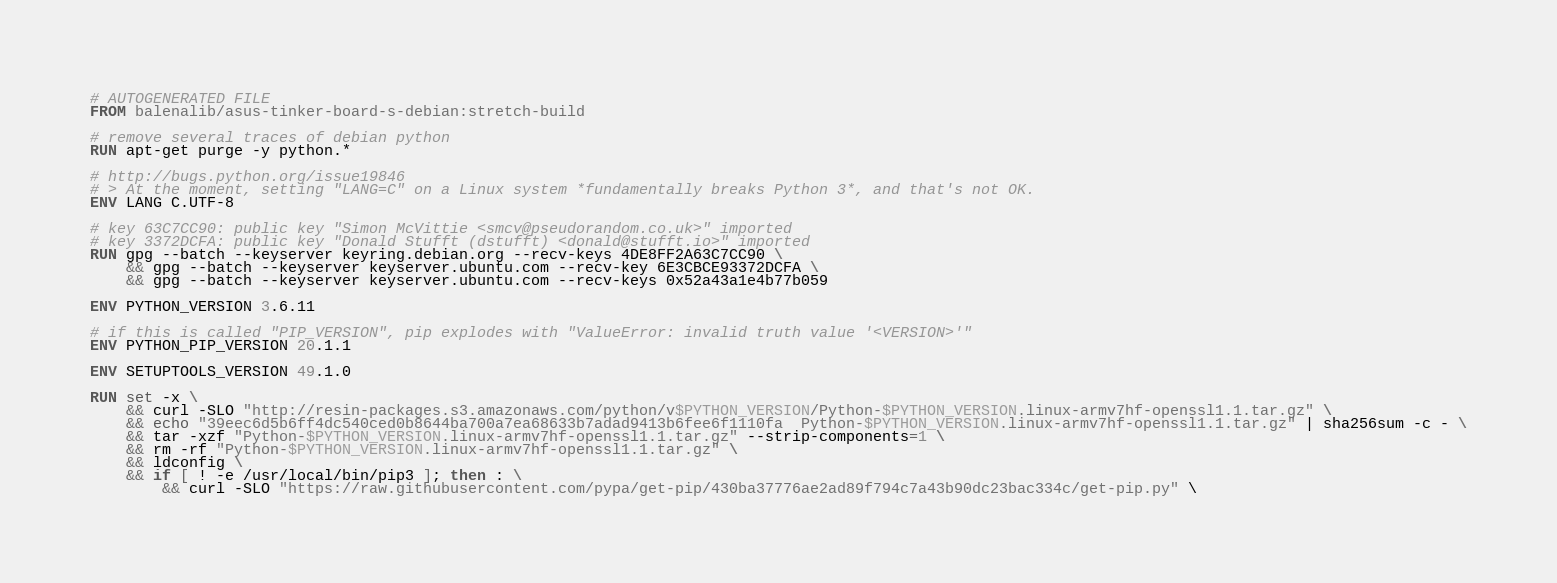Convert code to text. <code><loc_0><loc_0><loc_500><loc_500><_Dockerfile_># AUTOGENERATED FILE
FROM balenalib/asus-tinker-board-s-debian:stretch-build

# remove several traces of debian python
RUN apt-get purge -y python.*

# http://bugs.python.org/issue19846
# > At the moment, setting "LANG=C" on a Linux system *fundamentally breaks Python 3*, and that's not OK.
ENV LANG C.UTF-8

# key 63C7CC90: public key "Simon McVittie <smcv@pseudorandom.co.uk>" imported
# key 3372DCFA: public key "Donald Stufft (dstufft) <donald@stufft.io>" imported
RUN gpg --batch --keyserver keyring.debian.org --recv-keys 4DE8FF2A63C7CC90 \
	&& gpg --batch --keyserver keyserver.ubuntu.com --recv-key 6E3CBCE93372DCFA \
	&& gpg --batch --keyserver keyserver.ubuntu.com --recv-keys 0x52a43a1e4b77b059

ENV PYTHON_VERSION 3.6.11

# if this is called "PIP_VERSION", pip explodes with "ValueError: invalid truth value '<VERSION>'"
ENV PYTHON_PIP_VERSION 20.1.1

ENV SETUPTOOLS_VERSION 49.1.0

RUN set -x \
	&& curl -SLO "http://resin-packages.s3.amazonaws.com/python/v$PYTHON_VERSION/Python-$PYTHON_VERSION.linux-armv7hf-openssl1.1.tar.gz" \
	&& echo "39eec6d5b6ff4dc540ced0b8644ba700a7ea68633b7adad9413b6fee6f1110fa  Python-$PYTHON_VERSION.linux-armv7hf-openssl1.1.tar.gz" | sha256sum -c - \
	&& tar -xzf "Python-$PYTHON_VERSION.linux-armv7hf-openssl1.1.tar.gz" --strip-components=1 \
	&& rm -rf "Python-$PYTHON_VERSION.linux-armv7hf-openssl1.1.tar.gz" \
	&& ldconfig \
	&& if [ ! -e /usr/local/bin/pip3 ]; then : \
		&& curl -SLO "https://raw.githubusercontent.com/pypa/get-pip/430ba37776ae2ad89f794c7a43b90dc23bac334c/get-pip.py" \</code> 